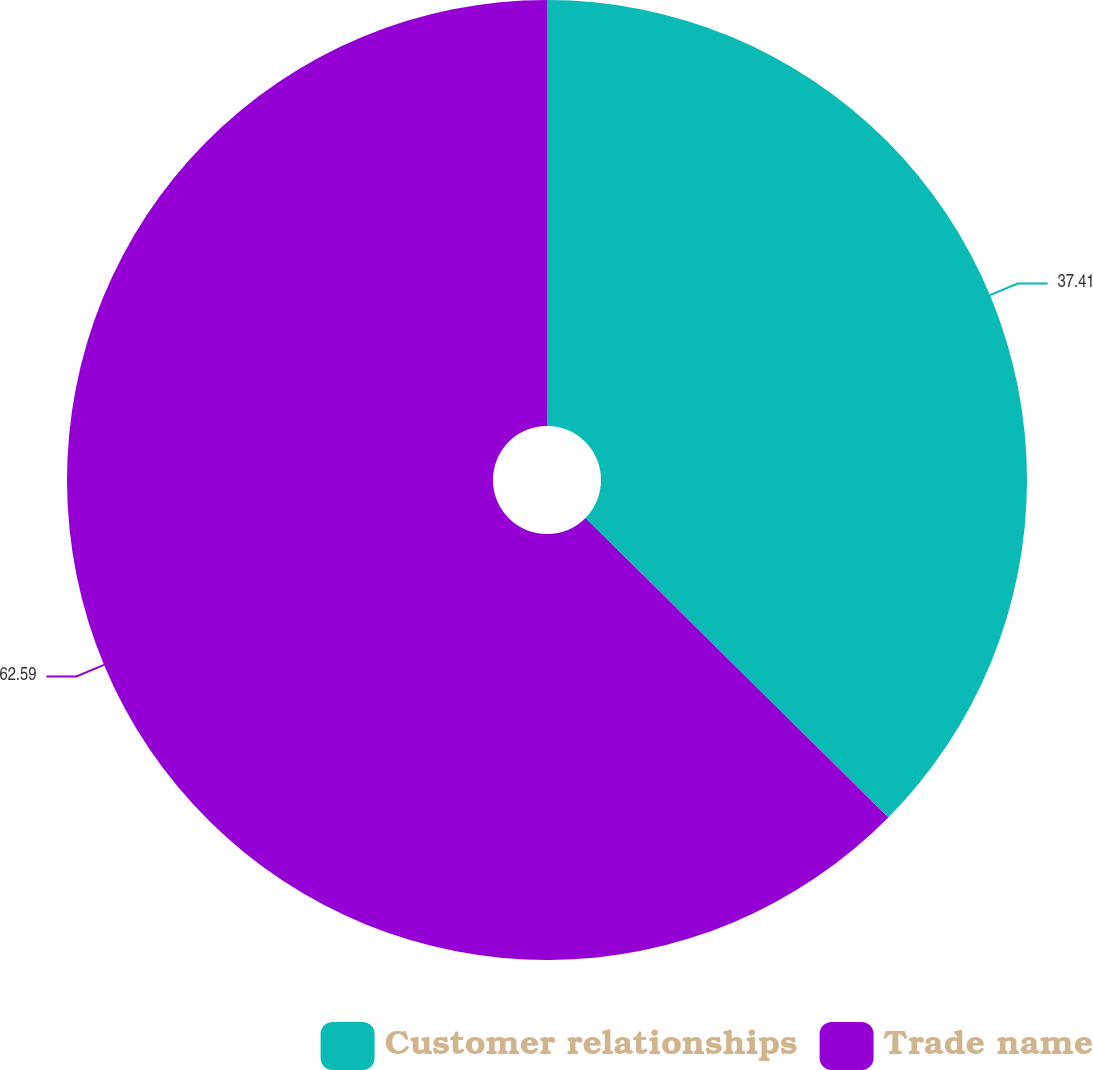Convert chart. <chart><loc_0><loc_0><loc_500><loc_500><pie_chart><fcel>Customer relationships<fcel>Trade name<nl><fcel>37.41%<fcel>62.59%<nl></chart> 